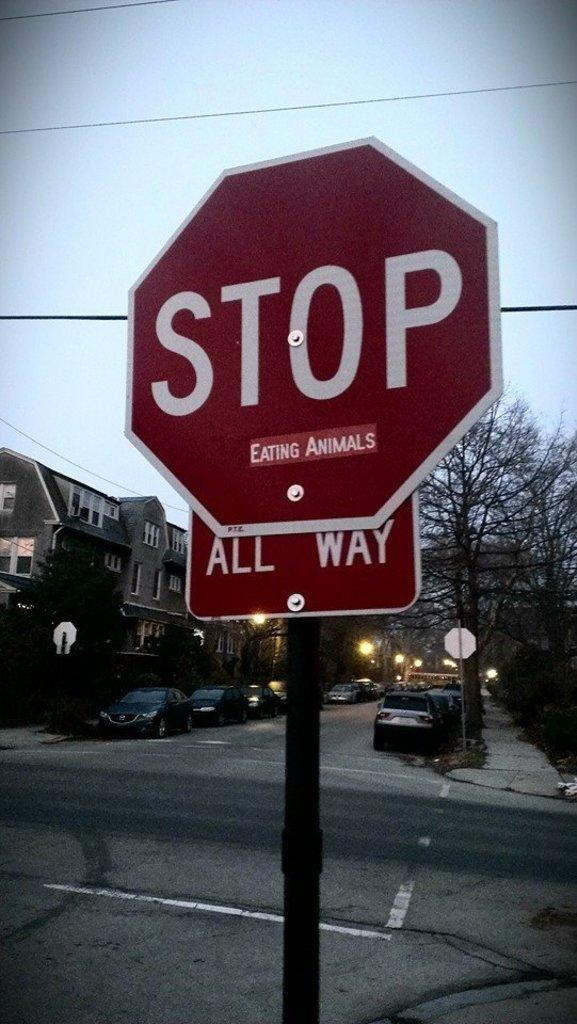<image>
Offer a succinct explanation of the picture presented. You must stop in all directions before proceeding through the intersection. 